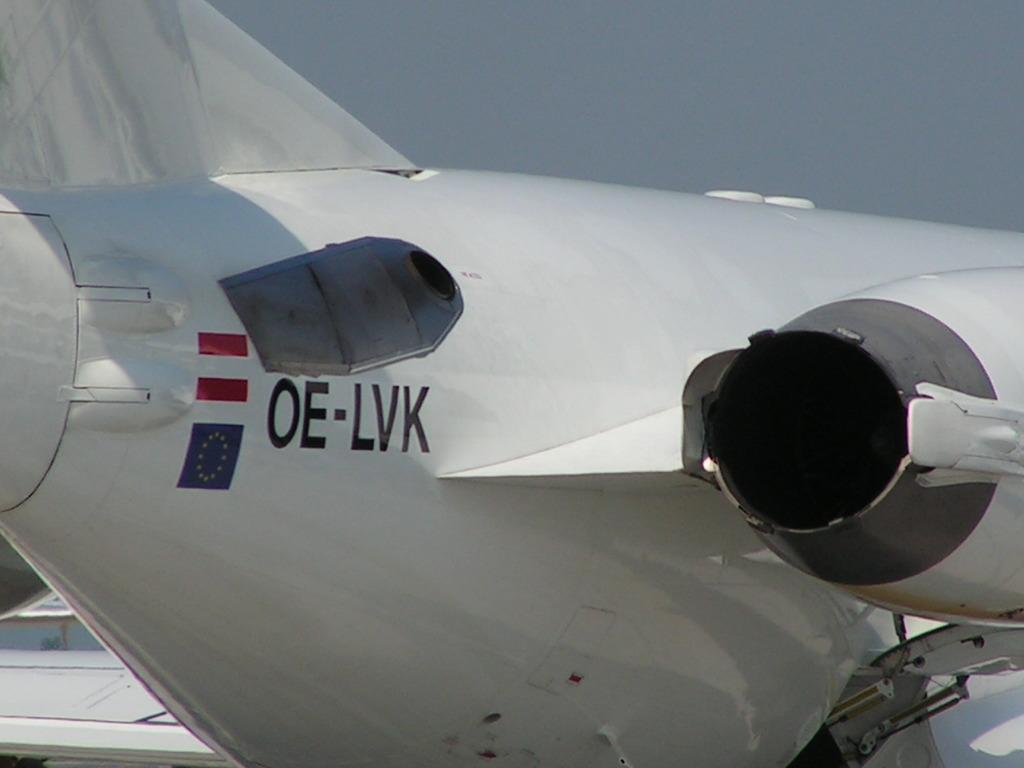<image>
Provide a brief description of the given image. The rear part of a plane on which the letters "OE-LVK" are written. 